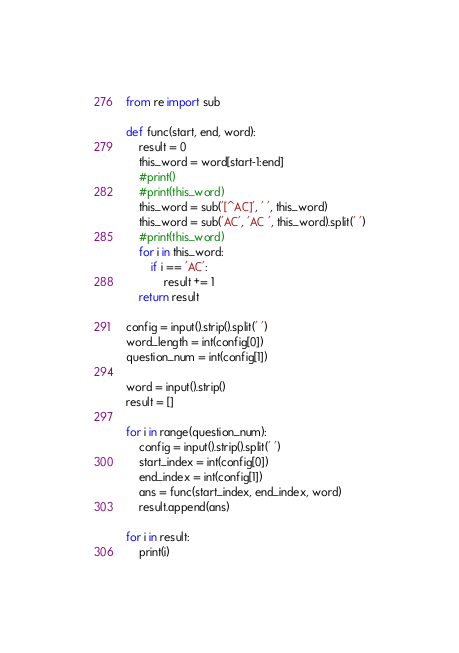Convert code to text. <code><loc_0><loc_0><loc_500><loc_500><_Python_>from re import sub

def func(start, end, word):
    result = 0
    this_word = word[start-1:end]
    #print()
    #print(this_word)
    this_word = sub('[^AC]', ' ', this_word)
    this_word = sub('AC', 'AC ', this_word).split(' ')
    #print(this_word)
    for i in this_word:
        if i == 'AC':
            result += 1
    return result

config = input().strip().split(' ')
word_length = int(config[0])
question_num = int(config[1])

word = input().strip()
result = []

for i in range(question_num):
    config = input().strip().split(' ')
    start_index = int(config[0])
    end_index = int(config[1])
    ans = func(start_index, end_index, word)
    result.append(ans)

for i in result:
    print(i)</code> 